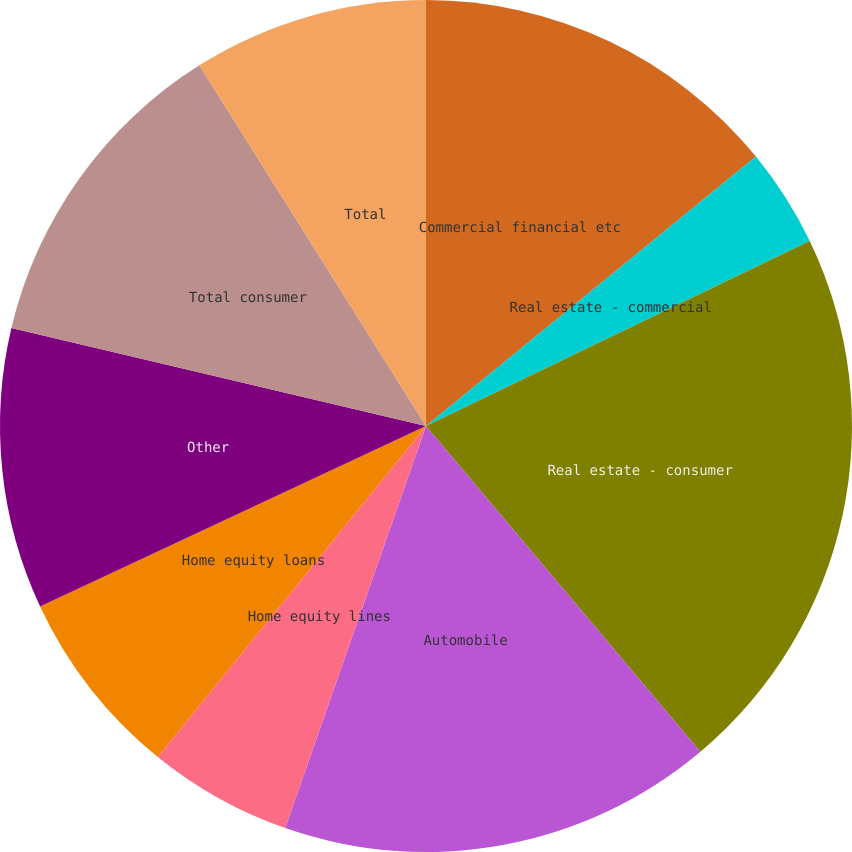Convert chart. <chart><loc_0><loc_0><loc_500><loc_500><pie_chart><fcel>Commercial financial etc<fcel>Real estate - commercial<fcel>Real estate - consumer<fcel>Automobile<fcel>Home equity lines<fcel>Home equity loans<fcel>Other<fcel>Total consumer<fcel>Total<nl><fcel>14.1%<fcel>3.75%<fcel>21.01%<fcel>16.5%<fcel>5.48%<fcel>7.2%<fcel>10.65%<fcel>12.38%<fcel>8.93%<nl></chart> 